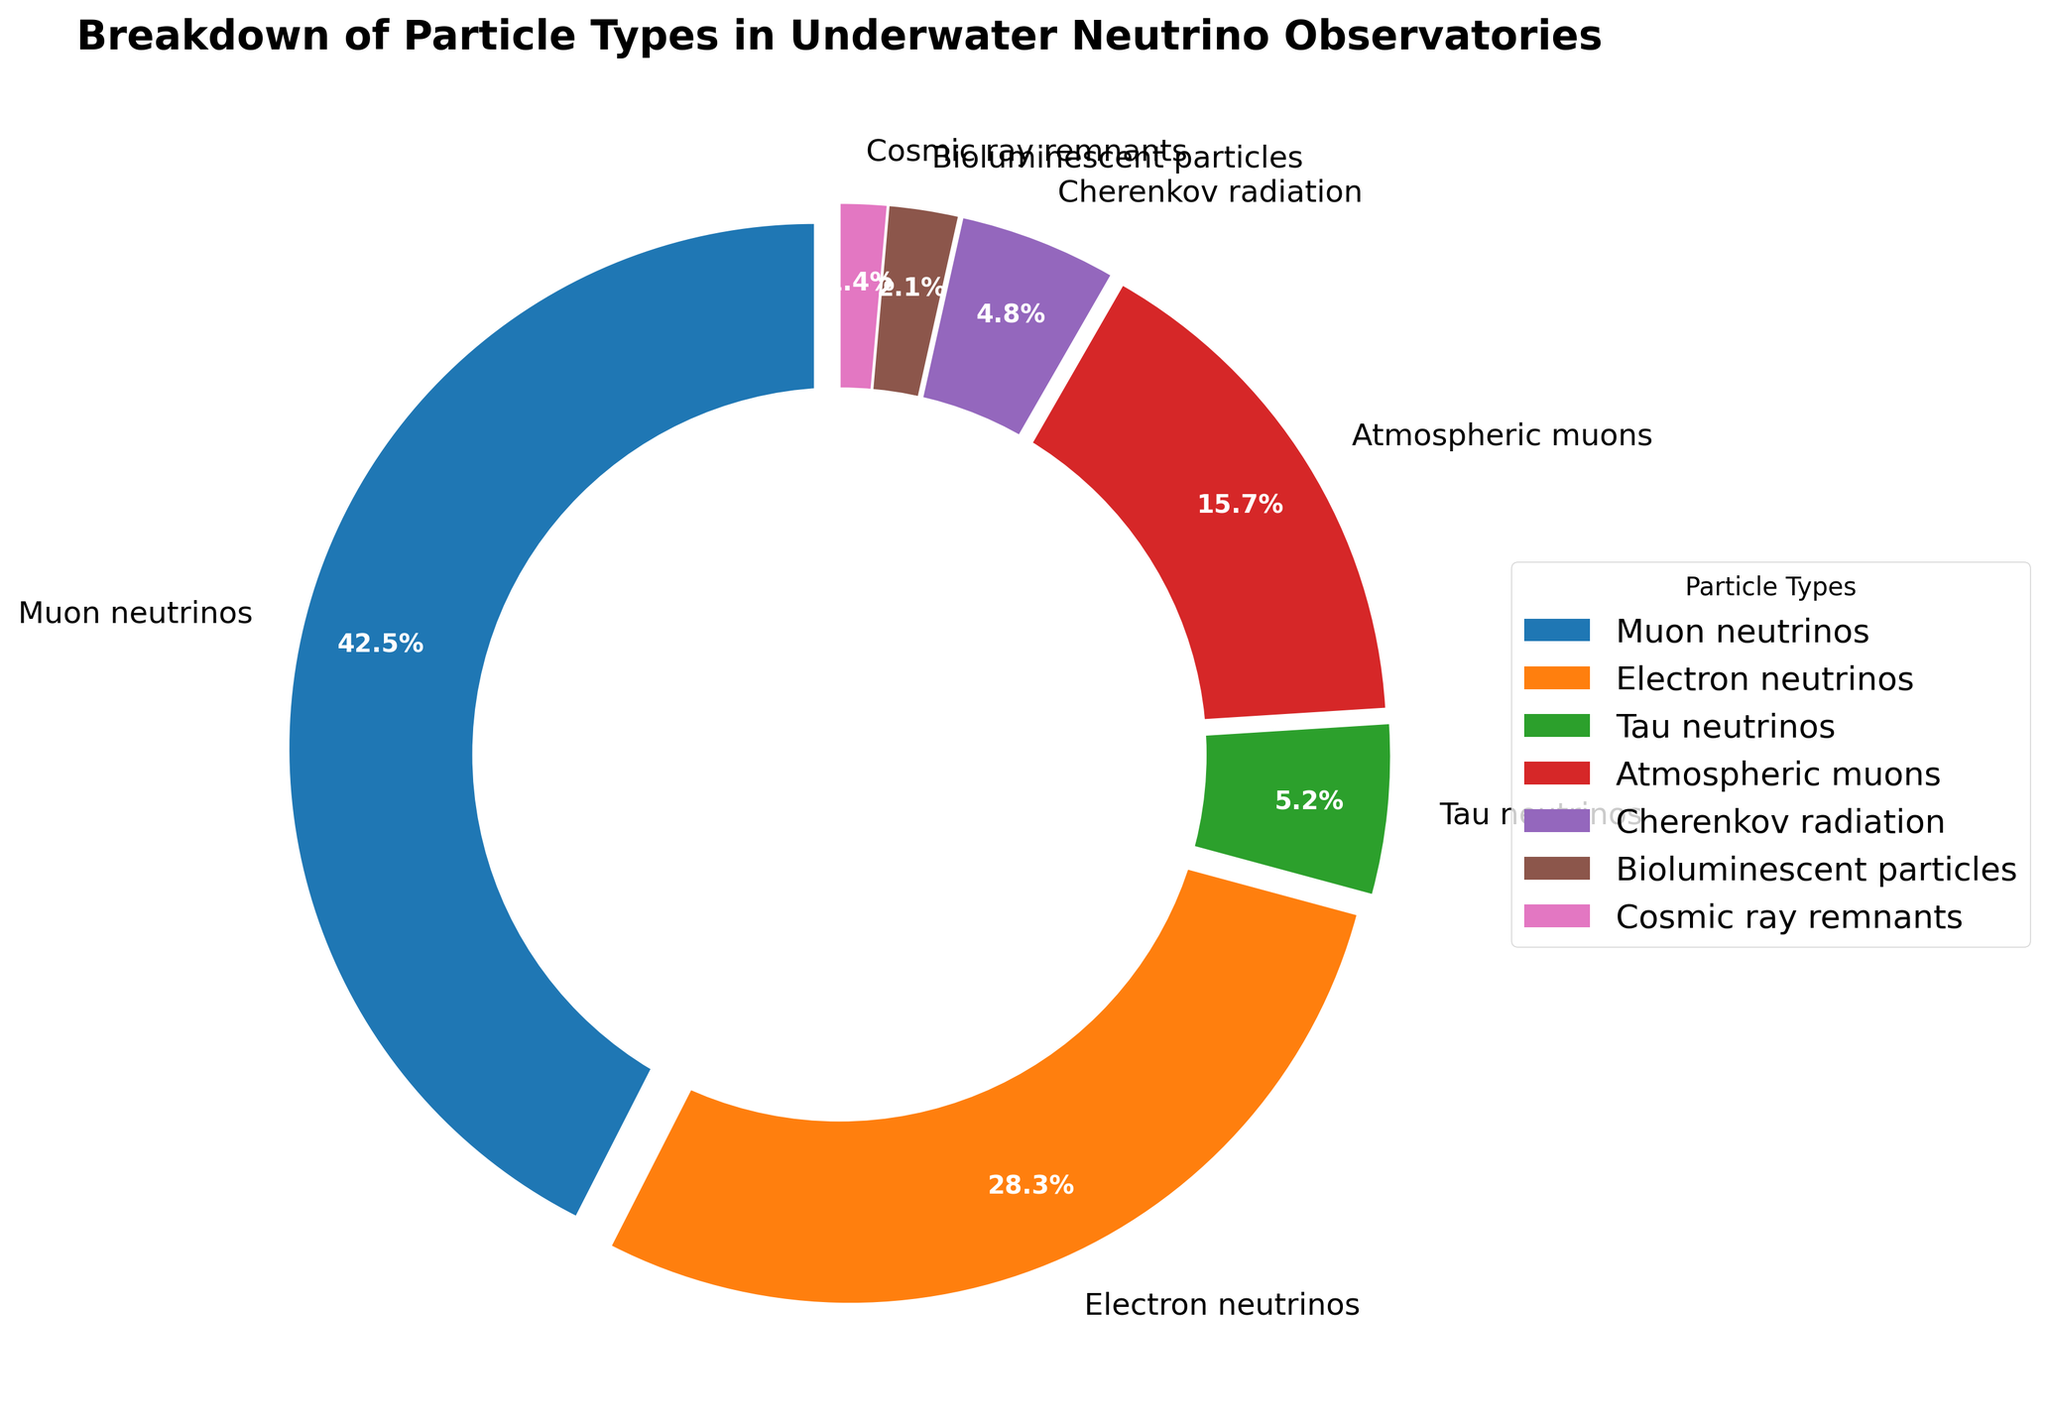What is the most common particle type detected in underwater neutrino observatories? To determine the most common particle type, look at the segment with the largest percentage in the pie chart. The label for the segment shows "Muon neutrinos" at 42.5%, which is the highest among the particle types.
Answer: Muon neutrinos Which particle type is the least common according to the pie chart? The least common particle type can be found by identifying the segment with the smallest percentage. The pie chart shows that "Cosmic ray remnants" have the smallest size, labeled at 1.4%.
Answer: Cosmic ray remnants What is the combined percentage of atmospheric muons and bioluminescent particles? To find the combined percentage, sum the individual percentages of atmospheric muons and bioluminescent particles. Atmospheric muons are 15.7% and bioluminescent particles are 2.1%. Adding them together: 15.7% + 2.1% = 17.8%.
Answer: 17.8% How much larger is the percentage of electron neutrinos compared to tau neutrinos? To find how much larger the percentage of electron neutrinos is compared to tau neutrinos, subtract the percentage of tau neutrinos from that of electron neutrinos. Electron neutrinos are at 28.3%, and tau neutrinos are at 5.2%. So, 28.3% - 5.2% = 23.1%.
Answer: 23.1% Which types of particles together make up more than half of the total detected particles? To determine which particle types together make up more than half (50%), add the percentages of the largest segments until the sum exceeds 50%. Muon neutrinos (42.5%) and electron neutrinos (28.3%) together make up 42.5% + 28.3% = 70.8%, which is more than half.
Answer: Muon neutrinos and Electron neutrinos By what percentage do muon neutrinos exceed the sum of tau neutrinos and atmospheric muons? First, find the sum of tau neutrinos and atmospheric muons: 5.2% + 15.7% = 20.9%. Then, subtract this sum from the percentage of muon neutrinos: 42.5% - 20.9% = 21.6%.
Answer: 21.6% What percentage of particles detected are neutrinos of any type? To find the total percentage of neutrinos, add the percentages of muon neutrinos, electron neutrinos, and tau neutrinos. Muon neutrinos: 42.5%, electron neutrinos: 28.3%, tau neutrinos: 5.2%. Total: 42.5% + 28.3% + 5.2% = 76%.
Answer: 76% Which color represents the tau neutrinos section on the pie chart? To identify the color representing tau neutrinos, look for the section labeled "Tau neutrinos" on the pie chart. Tau neutrinos are represented by a segment colored in green.
Answer: Green 